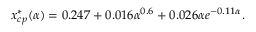<formula> <loc_0><loc_0><loc_500><loc_500>\begin{array} { r } { { x } _ { c p } ^ { * } ( \alpha ) = 0 . 2 4 7 + 0 . 0 1 6 \alpha ^ { 0 . 6 } + 0 . 0 2 6 { \alpha } e ^ { - 0 . 1 1 \alpha } . } \end{array}</formula> 